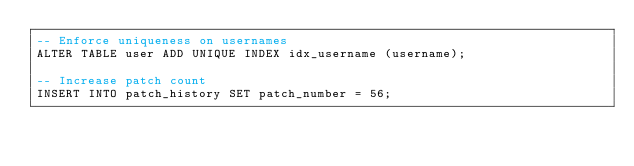Convert code to text. <code><loc_0><loc_0><loc_500><loc_500><_SQL_>-- Enforce uniqueness on usernames
ALTER TABLE user ADD UNIQUE INDEX idx_username (username);
    
-- Increase patch count
INSERT INTO patch_history SET patch_number = 56;
</code> 